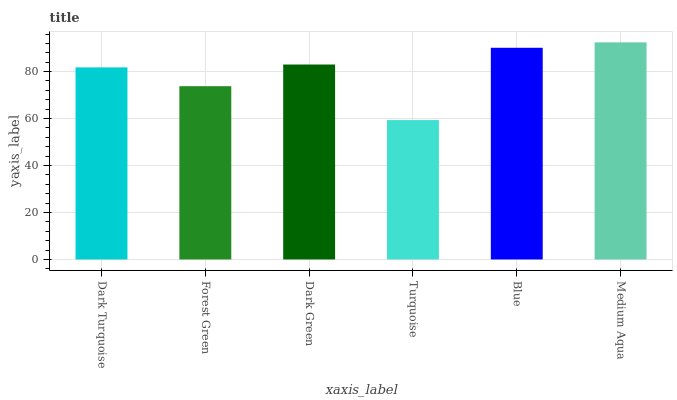Is Forest Green the minimum?
Answer yes or no. No. Is Forest Green the maximum?
Answer yes or no. No. Is Dark Turquoise greater than Forest Green?
Answer yes or no. Yes. Is Forest Green less than Dark Turquoise?
Answer yes or no. Yes. Is Forest Green greater than Dark Turquoise?
Answer yes or no. No. Is Dark Turquoise less than Forest Green?
Answer yes or no. No. Is Dark Green the high median?
Answer yes or no. Yes. Is Dark Turquoise the low median?
Answer yes or no. Yes. Is Blue the high median?
Answer yes or no. No. Is Dark Green the low median?
Answer yes or no. No. 